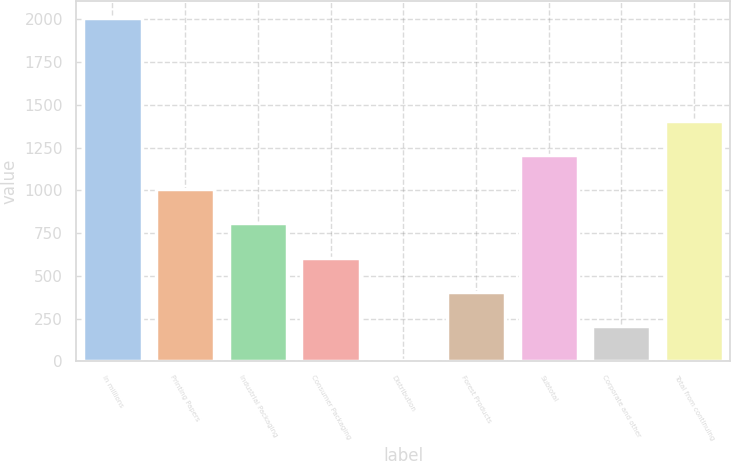Convert chart to OTSL. <chart><loc_0><loc_0><loc_500><loc_500><bar_chart><fcel>In millions<fcel>Printing Papers<fcel>Industrial Packaging<fcel>Consumer Packaging<fcel>Distribution<fcel>Forest Products<fcel>Subtotal<fcel>Corporate and other<fcel>Total from continuing<nl><fcel>2006<fcel>1006<fcel>806<fcel>606<fcel>6<fcel>406<fcel>1206<fcel>206<fcel>1406<nl></chart> 